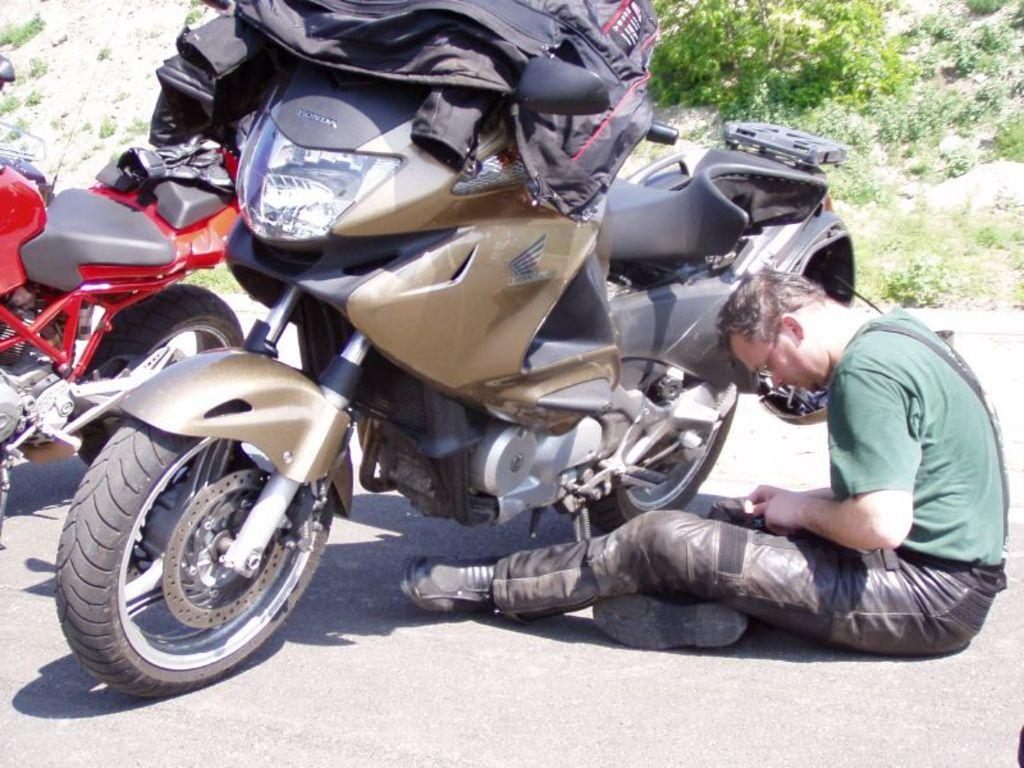What is the man in the image doing? The man is sitting on the road in the image. What type of vehicles can be seen in the image? There are motorbikes in the image. What clothing item is visible in the image? There is a jacket in the image. What can be seen in the background of the image? There are plants in the background of the image. What book is the man reading while sitting on the road? There is no book present in the image; the man is simply sitting on the road. 